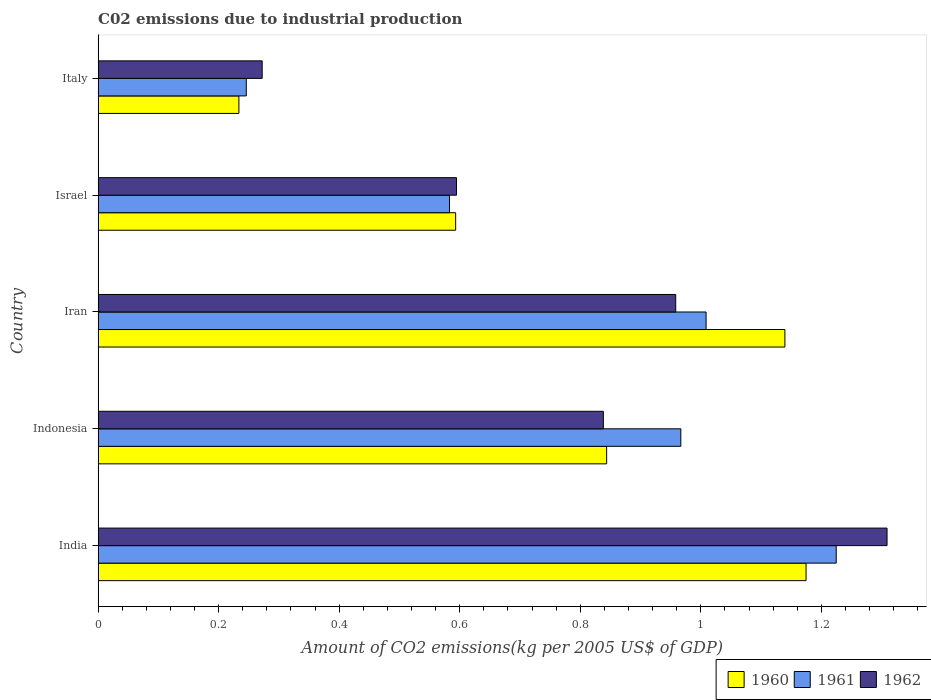How many different coloured bars are there?
Provide a short and direct response. 3. Are the number of bars on each tick of the Y-axis equal?
Offer a very short reply. Yes. How many bars are there on the 3rd tick from the top?
Offer a terse response. 3. How many bars are there on the 1st tick from the bottom?
Keep it short and to the point. 3. What is the label of the 1st group of bars from the top?
Your response must be concise. Italy. What is the amount of CO2 emitted due to industrial production in 1962 in India?
Provide a succinct answer. 1.31. Across all countries, what is the maximum amount of CO2 emitted due to industrial production in 1960?
Give a very brief answer. 1.17. Across all countries, what is the minimum amount of CO2 emitted due to industrial production in 1962?
Keep it short and to the point. 0.27. What is the total amount of CO2 emitted due to industrial production in 1962 in the graph?
Make the answer very short. 3.97. What is the difference between the amount of CO2 emitted due to industrial production in 1961 in Iran and that in Israel?
Keep it short and to the point. 0.43. What is the difference between the amount of CO2 emitted due to industrial production in 1961 in Israel and the amount of CO2 emitted due to industrial production in 1960 in Iran?
Ensure brevity in your answer.  -0.56. What is the average amount of CO2 emitted due to industrial production in 1961 per country?
Provide a short and direct response. 0.81. What is the difference between the amount of CO2 emitted due to industrial production in 1962 and amount of CO2 emitted due to industrial production in 1961 in Indonesia?
Offer a very short reply. -0.13. In how many countries, is the amount of CO2 emitted due to industrial production in 1960 greater than 0.7200000000000001 kg?
Provide a succinct answer. 3. What is the ratio of the amount of CO2 emitted due to industrial production in 1960 in India to that in Israel?
Provide a short and direct response. 1.98. Is the difference between the amount of CO2 emitted due to industrial production in 1962 in India and Indonesia greater than the difference between the amount of CO2 emitted due to industrial production in 1961 in India and Indonesia?
Your answer should be compact. Yes. What is the difference between the highest and the second highest amount of CO2 emitted due to industrial production in 1960?
Keep it short and to the point. 0.04. What is the difference between the highest and the lowest amount of CO2 emitted due to industrial production in 1960?
Make the answer very short. 0.94. Is the sum of the amount of CO2 emitted due to industrial production in 1961 in Indonesia and Italy greater than the maximum amount of CO2 emitted due to industrial production in 1960 across all countries?
Your answer should be very brief. Yes. What does the 3rd bar from the top in Israel represents?
Keep it short and to the point. 1960. How many countries are there in the graph?
Your answer should be compact. 5. Are the values on the major ticks of X-axis written in scientific E-notation?
Provide a succinct answer. No. Does the graph contain any zero values?
Ensure brevity in your answer.  No. Does the graph contain grids?
Keep it short and to the point. No. Where does the legend appear in the graph?
Make the answer very short. Bottom right. How many legend labels are there?
Ensure brevity in your answer.  3. What is the title of the graph?
Provide a succinct answer. C02 emissions due to industrial production. Does "1974" appear as one of the legend labels in the graph?
Offer a very short reply. No. What is the label or title of the X-axis?
Provide a succinct answer. Amount of CO2 emissions(kg per 2005 US$ of GDP). What is the Amount of CO2 emissions(kg per 2005 US$ of GDP) of 1960 in India?
Your answer should be compact. 1.17. What is the Amount of CO2 emissions(kg per 2005 US$ of GDP) in 1961 in India?
Your response must be concise. 1.22. What is the Amount of CO2 emissions(kg per 2005 US$ of GDP) of 1962 in India?
Provide a succinct answer. 1.31. What is the Amount of CO2 emissions(kg per 2005 US$ of GDP) in 1960 in Indonesia?
Provide a succinct answer. 0.84. What is the Amount of CO2 emissions(kg per 2005 US$ of GDP) of 1961 in Indonesia?
Offer a terse response. 0.97. What is the Amount of CO2 emissions(kg per 2005 US$ of GDP) of 1962 in Indonesia?
Offer a very short reply. 0.84. What is the Amount of CO2 emissions(kg per 2005 US$ of GDP) of 1960 in Iran?
Offer a terse response. 1.14. What is the Amount of CO2 emissions(kg per 2005 US$ of GDP) of 1961 in Iran?
Make the answer very short. 1.01. What is the Amount of CO2 emissions(kg per 2005 US$ of GDP) of 1962 in Iran?
Offer a very short reply. 0.96. What is the Amount of CO2 emissions(kg per 2005 US$ of GDP) in 1960 in Israel?
Your answer should be compact. 0.59. What is the Amount of CO2 emissions(kg per 2005 US$ of GDP) of 1961 in Israel?
Make the answer very short. 0.58. What is the Amount of CO2 emissions(kg per 2005 US$ of GDP) in 1962 in Israel?
Provide a succinct answer. 0.59. What is the Amount of CO2 emissions(kg per 2005 US$ of GDP) in 1960 in Italy?
Ensure brevity in your answer.  0.23. What is the Amount of CO2 emissions(kg per 2005 US$ of GDP) in 1961 in Italy?
Keep it short and to the point. 0.25. What is the Amount of CO2 emissions(kg per 2005 US$ of GDP) in 1962 in Italy?
Keep it short and to the point. 0.27. Across all countries, what is the maximum Amount of CO2 emissions(kg per 2005 US$ of GDP) of 1960?
Your answer should be very brief. 1.17. Across all countries, what is the maximum Amount of CO2 emissions(kg per 2005 US$ of GDP) in 1961?
Your answer should be compact. 1.22. Across all countries, what is the maximum Amount of CO2 emissions(kg per 2005 US$ of GDP) of 1962?
Your answer should be compact. 1.31. Across all countries, what is the minimum Amount of CO2 emissions(kg per 2005 US$ of GDP) in 1960?
Offer a very short reply. 0.23. Across all countries, what is the minimum Amount of CO2 emissions(kg per 2005 US$ of GDP) of 1961?
Offer a terse response. 0.25. Across all countries, what is the minimum Amount of CO2 emissions(kg per 2005 US$ of GDP) in 1962?
Make the answer very short. 0.27. What is the total Amount of CO2 emissions(kg per 2005 US$ of GDP) in 1960 in the graph?
Provide a short and direct response. 3.98. What is the total Amount of CO2 emissions(kg per 2005 US$ of GDP) of 1961 in the graph?
Make the answer very short. 4.03. What is the total Amount of CO2 emissions(kg per 2005 US$ of GDP) in 1962 in the graph?
Your answer should be compact. 3.97. What is the difference between the Amount of CO2 emissions(kg per 2005 US$ of GDP) in 1960 in India and that in Indonesia?
Provide a succinct answer. 0.33. What is the difference between the Amount of CO2 emissions(kg per 2005 US$ of GDP) of 1961 in India and that in Indonesia?
Your response must be concise. 0.26. What is the difference between the Amount of CO2 emissions(kg per 2005 US$ of GDP) of 1962 in India and that in Indonesia?
Give a very brief answer. 0.47. What is the difference between the Amount of CO2 emissions(kg per 2005 US$ of GDP) of 1960 in India and that in Iran?
Make the answer very short. 0.04. What is the difference between the Amount of CO2 emissions(kg per 2005 US$ of GDP) in 1961 in India and that in Iran?
Make the answer very short. 0.22. What is the difference between the Amount of CO2 emissions(kg per 2005 US$ of GDP) of 1962 in India and that in Iran?
Provide a succinct answer. 0.35. What is the difference between the Amount of CO2 emissions(kg per 2005 US$ of GDP) of 1960 in India and that in Israel?
Your answer should be compact. 0.58. What is the difference between the Amount of CO2 emissions(kg per 2005 US$ of GDP) of 1961 in India and that in Israel?
Provide a short and direct response. 0.64. What is the difference between the Amount of CO2 emissions(kg per 2005 US$ of GDP) in 1962 in India and that in Israel?
Offer a very short reply. 0.71. What is the difference between the Amount of CO2 emissions(kg per 2005 US$ of GDP) of 1960 in India and that in Italy?
Ensure brevity in your answer.  0.94. What is the difference between the Amount of CO2 emissions(kg per 2005 US$ of GDP) in 1961 in India and that in Italy?
Offer a terse response. 0.98. What is the difference between the Amount of CO2 emissions(kg per 2005 US$ of GDP) in 1962 in India and that in Italy?
Provide a succinct answer. 1.04. What is the difference between the Amount of CO2 emissions(kg per 2005 US$ of GDP) of 1960 in Indonesia and that in Iran?
Your answer should be compact. -0.3. What is the difference between the Amount of CO2 emissions(kg per 2005 US$ of GDP) of 1961 in Indonesia and that in Iran?
Your answer should be compact. -0.04. What is the difference between the Amount of CO2 emissions(kg per 2005 US$ of GDP) in 1962 in Indonesia and that in Iran?
Your answer should be very brief. -0.12. What is the difference between the Amount of CO2 emissions(kg per 2005 US$ of GDP) in 1960 in Indonesia and that in Israel?
Offer a terse response. 0.25. What is the difference between the Amount of CO2 emissions(kg per 2005 US$ of GDP) in 1961 in Indonesia and that in Israel?
Ensure brevity in your answer.  0.38. What is the difference between the Amount of CO2 emissions(kg per 2005 US$ of GDP) in 1962 in Indonesia and that in Israel?
Give a very brief answer. 0.24. What is the difference between the Amount of CO2 emissions(kg per 2005 US$ of GDP) in 1960 in Indonesia and that in Italy?
Make the answer very short. 0.61. What is the difference between the Amount of CO2 emissions(kg per 2005 US$ of GDP) in 1961 in Indonesia and that in Italy?
Your answer should be compact. 0.72. What is the difference between the Amount of CO2 emissions(kg per 2005 US$ of GDP) in 1962 in Indonesia and that in Italy?
Ensure brevity in your answer.  0.57. What is the difference between the Amount of CO2 emissions(kg per 2005 US$ of GDP) of 1960 in Iran and that in Israel?
Provide a succinct answer. 0.55. What is the difference between the Amount of CO2 emissions(kg per 2005 US$ of GDP) in 1961 in Iran and that in Israel?
Provide a succinct answer. 0.43. What is the difference between the Amount of CO2 emissions(kg per 2005 US$ of GDP) in 1962 in Iran and that in Israel?
Offer a very short reply. 0.36. What is the difference between the Amount of CO2 emissions(kg per 2005 US$ of GDP) in 1960 in Iran and that in Italy?
Offer a terse response. 0.91. What is the difference between the Amount of CO2 emissions(kg per 2005 US$ of GDP) in 1961 in Iran and that in Italy?
Give a very brief answer. 0.76. What is the difference between the Amount of CO2 emissions(kg per 2005 US$ of GDP) in 1962 in Iran and that in Italy?
Your answer should be compact. 0.69. What is the difference between the Amount of CO2 emissions(kg per 2005 US$ of GDP) in 1960 in Israel and that in Italy?
Make the answer very short. 0.36. What is the difference between the Amount of CO2 emissions(kg per 2005 US$ of GDP) in 1961 in Israel and that in Italy?
Give a very brief answer. 0.34. What is the difference between the Amount of CO2 emissions(kg per 2005 US$ of GDP) of 1962 in Israel and that in Italy?
Provide a short and direct response. 0.32. What is the difference between the Amount of CO2 emissions(kg per 2005 US$ of GDP) of 1960 in India and the Amount of CO2 emissions(kg per 2005 US$ of GDP) of 1961 in Indonesia?
Your answer should be compact. 0.21. What is the difference between the Amount of CO2 emissions(kg per 2005 US$ of GDP) in 1960 in India and the Amount of CO2 emissions(kg per 2005 US$ of GDP) in 1962 in Indonesia?
Offer a very short reply. 0.34. What is the difference between the Amount of CO2 emissions(kg per 2005 US$ of GDP) in 1961 in India and the Amount of CO2 emissions(kg per 2005 US$ of GDP) in 1962 in Indonesia?
Keep it short and to the point. 0.39. What is the difference between the Amount of CO2 emissions(kg per 2005 US$ of GDP) of 1960 in India and the Amount of CO2 emissions(kg per 2005 US$ of GDP) of 1961 in Iran?
Give a very brief answer. 0.17. What is the difference between the Amount of CO2 emissions(kg per 2005 US$ of GDP) of 1960 in India and the Amount of CO2 emissions(kg per 2005 US$ of GDP) of 1962 in Iran?
Ensure brevity in your answer.  0.22. What is the difference between the Amount of CO2 emissions(kg per 2005 US$ of GDP) in 1961 in India and the Amount of CO2 emissions(kg per 2005 US$ of GDP) in 1962 in Iran?
Offer a very short reply. 0.27. What is the difference between the Amount of CO2 emissions(kg per 2005 US$ of GDP) in 1960 in India and the Amount of CO2 emissions(kg per 2005 US$ of GDP) in 1961 in Israel?
Make the answer very short. 0.59. What is the difference between the Amount of CO2 emissions(kg per 2005 US$ of GDP) in 1960 in India and the Amount of CO2 emissions(kg per 2005 US$ of GDP) in 1962 in Israel?
Your answer should be compact. 0.58. What is the difference between the Amount of CO2 emissions(kg per 2005 US$ of GDP) of 1961 in India and the Amount of CO2 emissions(kg per 2005 US$ of GDP) of 1962 in Israel?
Give a very brief answer. 0.63. What is the difference between the Amount of CO2 emissions(kg per 2005 US$ of GDP) in 1960 in India and the Amount of CO2 emissions(kg per 2005 US$ of GDP) in 1961 in Italy?
Offer a terse response. 0.93. What is the difference between the Amount of CO2 emissions(kg per 2005 US$ of GDP) of 1960 in India and the Amount of CO2 emissions(kg per 2005 US$ of GDP) of 1962 in Italy?
Keep it short and to the point. 0.9. What is the difference between the Amount of CO2 emissions(kg per 2005 US$ of GDP) of 1960 in Indonesia and the Amount of CO2 emissions(kg per 2005 US$ of GDP) of 1961 in Iran?
Your answer should be very brief. -0.17. What is the difference between the Amount of CO2 emissions(kg per 2005 US$ of GDP) of 1960 in Indonesia and the Amount of CO2 emissions(kg per 2005 US$ of GDP) of 1962 in Iran?
Your response must be concise. -0.11. What is the difference between the Amount of CO2 emissions(kg per 2005 US$ of GDP) in 1961 in Indonesia and the Amount of CO2 emissions(kg per 2005 US$ of GDP) in 1962 in Iran?
Make the answer very short. 0.01. What is the difference between the Amount of CO2 emissions(kg per 2005 US$ of GDP) in 1960 in Indonesia and the Amount of CO2 emissions(kg per 2005 US$ of GDP) in 1961 in Israel?
Provide a succinct answer. 0.26. What is the difference between the Amount of CO2 emissions(kg per 2005 US$ of GDP) in 1960 in Indonesia and the Amount of CO2 emissions(kg per 2005 US$ of GDP) in 1962 in Israel?
Give a very brief answer. 0.25. What is the difference between the Amount of CO2 emissions(kg per 2005 US$ of GDP) of 1961 in Indonesia and the Amount of CO2 emissions(kg per 2005 US$ of GDP) of 1962 in Israel?
Your answer should be very brief. 0.37. What is the difference between the Amount of CO2 emissions(kg per 2005 US$ of GDP) in 1960 in Indonesia and the Amount of CO2 emissions(kg per 2005 US$ of GDP) in 1961 in Italy?
Keep it short and to the point. 0.6. What is the difference between the Amount of CO2 emissions(kg per 2005 US$ of GDP) of 1960 in Indonesia and the Amount of CO2 emissions(kg per 2005 US$ of GDP) of 1962 in Italy?
Your answer should be very brief. 0.57. What is the difference between the Amount of CO2 emissions(kg per 2005 US$ of GDP) of 1961 in Indonesia and the Amount of CO2 emissions(kg per 2005 US$ of GDP) of 1962 in Italy?
Provide a short and direct response. 0.69. What is the difference between the Amount of CO2 emissions(kg per 2005 US$ of GDP) of 1960 in Iran and the Amount of CO2 emissions(kg per 2005 US$ of GDP) of 1961 in Israel?
Give a very brief answer. 0.56. What is the difference between the Amount of CO2 emissions(kg per 2005 US$ of GDP) of 1960 in Iran and the Amount of CO2 emissions(kg per 2005 US$ of GDP) of 1962 in Israel?
Provide a short and direct response. 0.54. What is the difference between the Amount of CO2 emissions(kg per 2005 US$ of GDP) in 1961 in Iran and the Amount of CO2 emissions(kg per 2005 US$ of GDP) in 1962 in Israel?
Provide a short and direct response. 0.41. What is the difference between the Amount of CO2 emissions(kg per 2005 US$ of GDP) of 1960 in Iran and the Amount of CO2 emissions(kg per 2005 US$ of GDP) of 1961 in Italy?
Provide a succinct answer. 0.89. What is the difference between the Amount of CO2 emissions(kg per 2005 US$ of GDP) in 1960 in Iran and the Amount of CO2 emissions(kg per 2005 US$ of GDP) in 1962 in Italy?
Your answer should be compact. 0.87. What is the difference between the Amount of CO2 emissions(kg per 2005 US$ of GDP) in 1961 in Iran and the Amount of CO2 emissions(kg per 2005 US$ of GDP) in 1962 in Italy?
Give a very brief answer. 0.74. What is the difference between the Amount of CO2 emissions(kg per 2005 US$ of GDP) of 1960 in Israel and the Amount of CO2 emissions(kg per 2005 US$ of GDP) of 1961 in Italy?
Make the answer very short. 0.35. What is the difference between the Amount of CO2 emissions(kg per 2005 US$ of GDP) in 1960 in Israel and the Amount of CO2 emissions(kg per 2005 US$ of GDP) in 1962 in Italy?
Your answer should be very brief. 0.32. What is the difference between the Amount of CO2 emissions(kg per 2005 US$ of GDP) of 1961 in Israel and the Amount of CO2 emissions(kg per 2005 US$ of GDP) of 1962 in Italy?
Your response must be concise. 0.31. What is the average Amount of CO2 emissions(kg per 2005 US$ of GDP) in 1960 per country?
Provide a short and direct response. 0.8. What is the average Amount of CO2 emissions(kg per 2005 US$ of GDP) in 1961 per country?
Ensure brevity in your answer.  0.81. What is the average Amount of CO2 emissions(kg per 2005 US$ of GDP) of 1962 per country?
Keep it short and to the point. 0.79. What is the difference between the Amount of CO2 emissions(kg per 2005 US$ of GDP) of 1960 and Amount of CO2 emissions(kg per 2005 US$ of GDP) of 1961 in India?
Give a very brief answer. -0.05. What is the difference between the Amount of CO2 emissions(kg per 2005 US$ of GDP) of 1960 and Amount of CO2 emissions(kg per 2005 US$ of GDP) of 1962 in India?
Ensure brevity in your answer.  -0.13. What is the difference between the Amount of CO2 emissions(kg per 2005 US$ of GDP) of 1961 and Amount of CO2 emissions(kg per 2005 US$ of GDP) of 1962 in India?
Provide a short and direct response. -0.08. What is the difference between the Amount of CO2 emissions(kg per 2005 US$ of GDP) of 1960 and Amount of CO2 emissions(kg per 2005 US$ of GDP) of 1961 in Indonesia?
Your answer should be very brief. -0.12. What is the difference between the Amount of CO2 emissions(kg per 2005 US$ of GDP) of 1960 and Amount of CO2 emissions(kg per 2005 US$ of GDP) of 1962 in Indonesia?
Ensure brevity in your answer.  0.01. What is the difference between the Amount of CO2 emissions(kg per 2005 US$ of GDP) in 1961 and Amount of CO2 emissions(kg per 2005 US$ of GDP) in 1962 in Indonesia?
Offer a very short reply. 0.13. What is the difference between the Amount of CO2 emissions(kg per 2005 US$ of GDP) in 1960 and Amount of CO2 emissions(kg per 2005 US$ of GDP) in 1961 in Iran?
Keep it short and to the point. 0.13. What is the difference between the Amount of CO2 emissions(kg per 2005 US$ of GDP) of 1960 and Amount of CO2 emissions(kg per 2005 US$ of GDP) of 1962 in Iran?
Ensure brevity in your answer.  0.18. What is the difference between the Amount of CO2 emissions(kg per 2005 US$ of GDP) of 1961 and Amount of CO2 emissions(kg per 2005 US$ of GDP) of 1962 in Iran?
Your response must be concise. 0.05. What is the difference between the Amount of CO2 emissions(kg per 2005 US$ of GDP) of 1960 and Amount of CO2 emissions(kg per 2005 US$ of GDP) of 1961 in Israel?
Ensure brevity in your answer.  0.01. What is the difference between the Amount of CO2 emissions(kg per 2005 US$ of GDP) in 1960 and Amount of CO2 emissions(kg per 2005 US$ of GDP) in 1962 in Israel?
Offer a terse response. -0. What is the difference between the Amount of CO2 emissions(kg per 2005 US$ of GDP) of 1961 and Amount of CO2 emissions(kg per 2005 US$ of GDP) of 1962 in Israel?
Make the answer very short. -0.01. What is the difference between the Amount of CO2 emissions(kg per 2005 US$ of GDP) in 1960 and Amount of CO2 emissions(kg per 2005 US$ of GDP) in 1961 in Italy?
Provide a succinct answer. -0.01. What is the difference between the Amount of CO2 emissions(kg per 2005 US$ of GDP) in 1960 and Amount of CO2 emissions(kg per 2005 US$ of GDP) in 1962 in Italy?
Your response must be concise. -0.04. What is the difference between the Amount of CO2 emissions(kg per 2005 US$ of GDP) in 1961 and Amount of CO2 emissions(kg per 2005 US$ of GDP) in 1962 in Italy?
Your answer should be compact. -0.03. What is the ratio of the Amount of CO2 emissions(kg per 2005 US$ of GDP) of 1960 in India to that in Indonesia?
Offer a terse response. 1.39. What is the ratio of the Amount of CO2 emissions(kg per 2005 US$ of GDP) in 1961 in India to that in Indonesia?
Ensure brevity in your answer.  1.27. What is the ratio of the Amount of CO2 emissions(kg per 2005 US$ of GDP) in 1962 in India to that in Indonesia?
Make the answer very short. 1.56. What is the ratio of the Amount of CO2 emissions(kg per 2005 US$ of GDP) of 1960 in India to that in Iran?
Offer a terse response. 1.03. What is the ratio of the Amount of CO2 emissions(kg per 2005 US$ of GDP) in 1961 in India to that in Iran?
Offer a very short reply. 1.21. What is the ratio of the Amount of CO2 emissions(kg per 2005 US$ of GDP) of 1962 in India to that in Iran?
Your answer should be compact. 1.37. What is the ratio of the Amount of CO2 emissions(kg per 2005 US$ of GDP) in 1960 in India to that in Israel?
Provide a short and direct response. 1.98. What is the ratio of the Amount of CO2 emissions(kg per 2005 US$ of GDP) in 1961 in India to that in Israel?
Your answer should be very brief. 2.1. What is the ratio of the Amount of CO2 emissions(kg per 2005 US$ of GDP) in 1962 in India to that in Israel?
Your response must be concise. 2.2. What is the ratio of the Amount of CO2 emissions(kg per 2005 US$ of GDP) in 1960 in India to that in Italy?
Your response must be concise. 5.03. What is the ratio of the Amount of CO2 emissions(kg per 2005 US$ of GDP) in 1961 in India to that in Italy?
Give a very brief answer. 4.98. What is the ratio of the Amount of CO2 emissions(kg per 2005 US$ of GDP) in 1962 in India to that in Italy?
Your response must be concise. 4.81. What is the ratio of the Amount of CO2 emissions(kg per 2005 US$ of GDP) in 1960 in Indonesia to that in Iran?
Ensure brevity in your answer.  0.74. What is the ratio of the Amount of CO2 emissions(kg per 2005 US$ of GDP) in 1961 in Indonesia to that in Iran?
Your answer should be very brief. 0.96. What is the ratio of the Amount of CO2 emissions(kg per 2005 US$ of GDP) in 1962 in Indonesia to that in Iran?
Provide a succinct answer. 0.87. What is the ratio of the Amount of CO2 emissions(kg per 2005 US$ of GDP) in 1960 in Indonesia to that in Israel?
Offer a terse response. 1.42. What is the ratio of the Amount of CO2 emissions(kg per 2005 US$ of GDP) in 1961 in Indonesia to that in Israel?
Your answer should be very brief. 1.66. What is the ratio of the Amount of CO2 emissions(kg per 2005 US$ of GDP) in 1962 in Indonesia to that in Israel?
Ensure brevity in your answer.  1.41. What is the ratio of the Amount of CO2 emissions(kg per 2005 US$ of GDP) of 1960 in Indonesia to that in Italy?
Your answer should be very brief. 3.61. What is the ratio of the Amount of CO2 emissions(kg per 2005 US$ of GDP) of 1961 in Indonesia to that in Italy?
Offer a terse response. 3.93. What is the ratio of the Amount of CO2 emissions(kg per 2005 US$ of GDP) of 1962 in Indonesia to that in Italy?
Ensure brevity in your answer.  3.08. What is the ratio of the Amount of CO2 emissions(kg per 2005 US$ of GDP) of 1960 in Iran to that in Israel?
Your answer should be compact. 1.92. What is the ratio of the Amount of CO2 emissions(kg per 2005 US$ of GDP) in 1961 in Iran to that in Israel?
Provide a succinct answer. 1.73. What is the ratio of the Amount of CO2 emissions(kg per 2005 US$ of GDP) in 1962 in Iran to that in Israel?
Give a very brief answer. 1.61. What is the ratio of the Amount of CO2 emissions(kg per 2005 US$ of GDP) in 1960 in Iran to that in Italy?
Offer a very short reply. 4.88. What is the ratio of the Amount of CO2 emissions(kg per 2005 US$ of GDP) of 1961 in Iran to that in Italy?
Keep it short and to the point. 4.1. What is the ratio of the Amount of CO2 emissions(kg per 2005 US$ of GDP) in 1962 in Iran to that in Italy?
Provide a short and direct response. 3.52. What is the ratio of the Amount of CO2 emissions(kg per 2005 US$ of GDP) in 1960 in Israel to that in Italy?
Offer a terse response. 2.54. What is the ratio of the Amount of CO2 emissions(kg per 2005 US$ of GDP) of 1961 in Israel to that in Italy?
Your response must be concise. 2.37. What is the ratio of the Amount of CO2 emissions(kg per 2005 US$ of GDP) of 1962 in Israel to that in Italy?
Give a very brief answer. 2.18. What is the difference between the highest and the second highest Amount of CO2 emissions(kg per 2005 US$ of GDP) in 1960?
Your answer should be very brief. 0.04. What is the difference between the highest and the second highest Amount of CO2 emissions(kg per 2005 US$ of GDP) in 1961?
Offer a very short reply. 0.22. What is the difference between the highest and the second highest Amount of CO2 emissions(kg per 2005 US$ of GDP) in 1962?
Provide a succinct answer. 0.35. What is the difference between the highest and the lowest Amount of CO2 emissions(kg per 2005 US$ of GDP) in 1960?
Provide a short and direct response. 0.94. What is the difference between the highest and the lowest Amount of CO2 emissions(kg per 2005 US$ of GDP) in 1961?
Offer a very short reply. 0.98. What is the difference between the highest and the lowest Amount of CO2 emissions(kg per 2005 US$ of GDP) of 1962?
Offer a very short reply. 1.04. 